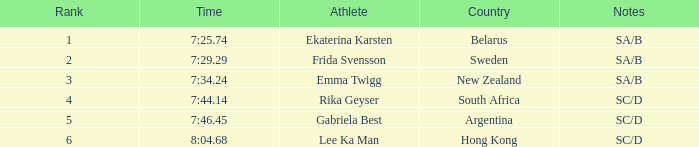What is the total rank for the athlete that had a race time of 7:34.24? 1.0. 